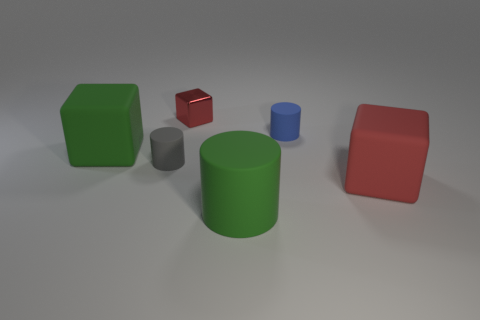There is a thing that is the same color as the small block; what is it made of?
Keep it short and to the point. Rubber. What color is the large block on the left side of the large green matte object that is in front of the green matte object on the left side of the small metal block?
Your answer should be compact. Green. Is the material of the red object on the left side of the green rubber cylinder the same as the large green block?
Offer a terse response. No. What number of other things are there of the same material as the blue object
Provide a succinct answer. 4. There is a green cube that is the same size as the red rubber object; what is its material?
Your answer should be compact. Rubber. There is a big green thing on the right side of the big green cube; is its shape the same as the green matte thing that is behind the large green cylinder?
Your answer should be compact. No. There is a gray object that is the same size as the blue matte cylinder; what shape is it?
Your answer should be compact. Cylinder. Is the big object that is on the right side of the blue matte cylinder made of the same material as the cylinder behind the tiny gray thing?
Give a very brief answer. Yes. Are there any tiny blue rubber cylinders to the left of the cylinder that is behind the gray matte cylinder?
Your answer should be very brief. No. What color is the other cube that is made of the same material as the green cube?
Offer a terse response. Red. 